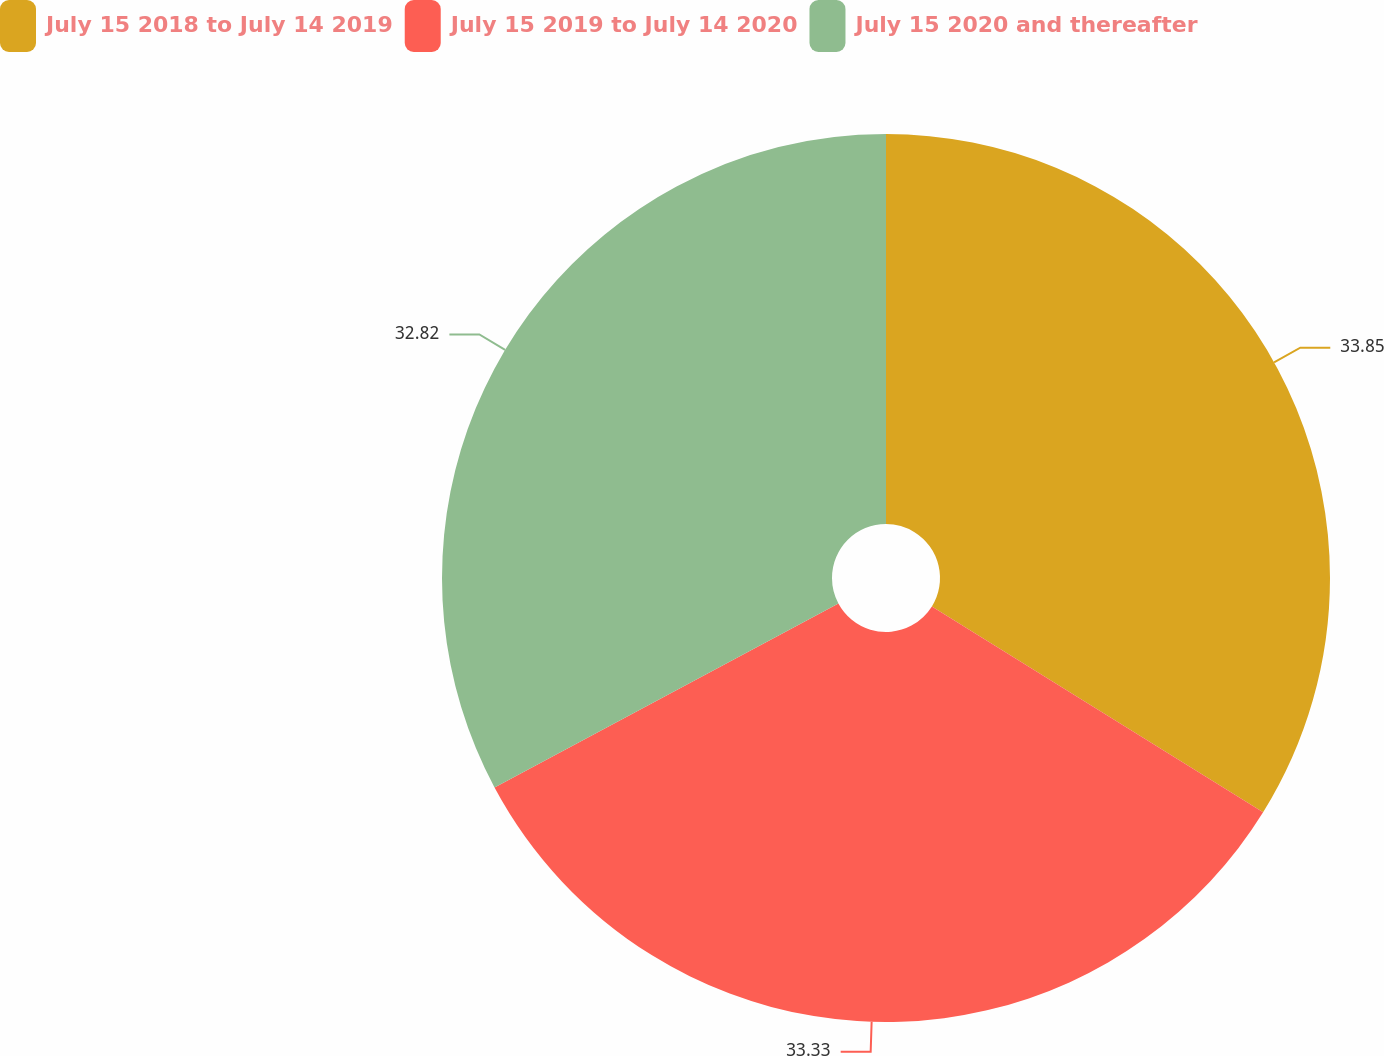Convert chart to OTSL. <chart><loc_0><loc_0><loc_500><loc_500><pie_chart><fcel>July 15 2018 to July 14 2019<fcel>July 15 2019 to July 14 2020<fcel>July 15 2020 and thereafter<nl><fcel>33.85%<fcel>33.33%<fcel>32.82%<nl></chart> 